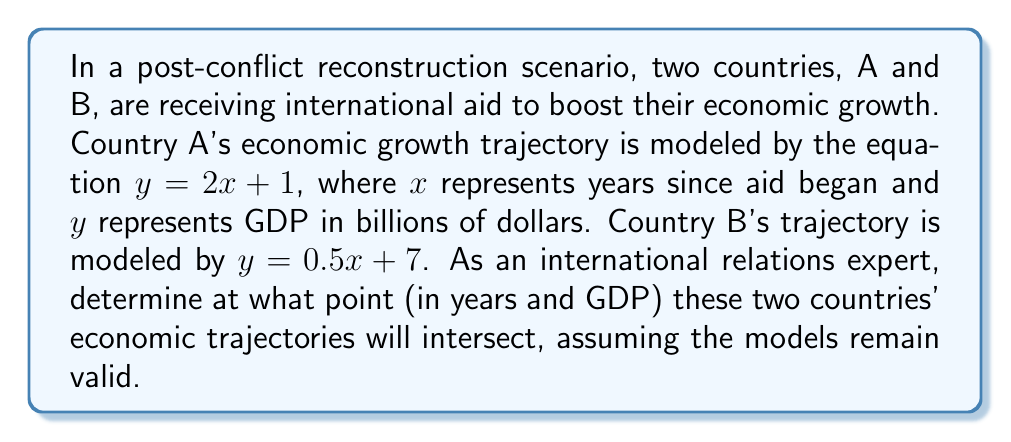What is the answer to this math problem? To find the intersection point of these two linear equations, we need to solve them simultaneously:

1) Set the equations equal to each other:
   $2x + 1 = 0.5x + 7$

2) Subtract $0.5x$ from both sides:
   $1.5x + 1 = 7$

3) Subtract 1 from both sides:
   $1.5x = 6$

4) Divide both sides by 1.5:
   $x = 4$

5) Now that we know the x-coordinate (years), we can substitute this value into either equation to find the y-coordinate (GDP). Let's use Country A's equation:

   $y = 2(4) + 1 = 8 + 1 = 9$

Therefore, the intersection point is (4, 9).

This means that after 4 years, both countries will have a GDP of 9 billion dollars.

To verify, we can check this point in Country B's equation:
$0.5(4) + 7 = 2 + 7 = 9$

This confirms our solution is correct.
Answer: The economic growth trajectories of Countries A and B will intersect after 4 years, when both countries reach a GDP of 9 billion dollars. The intersection point is (4, 9). 